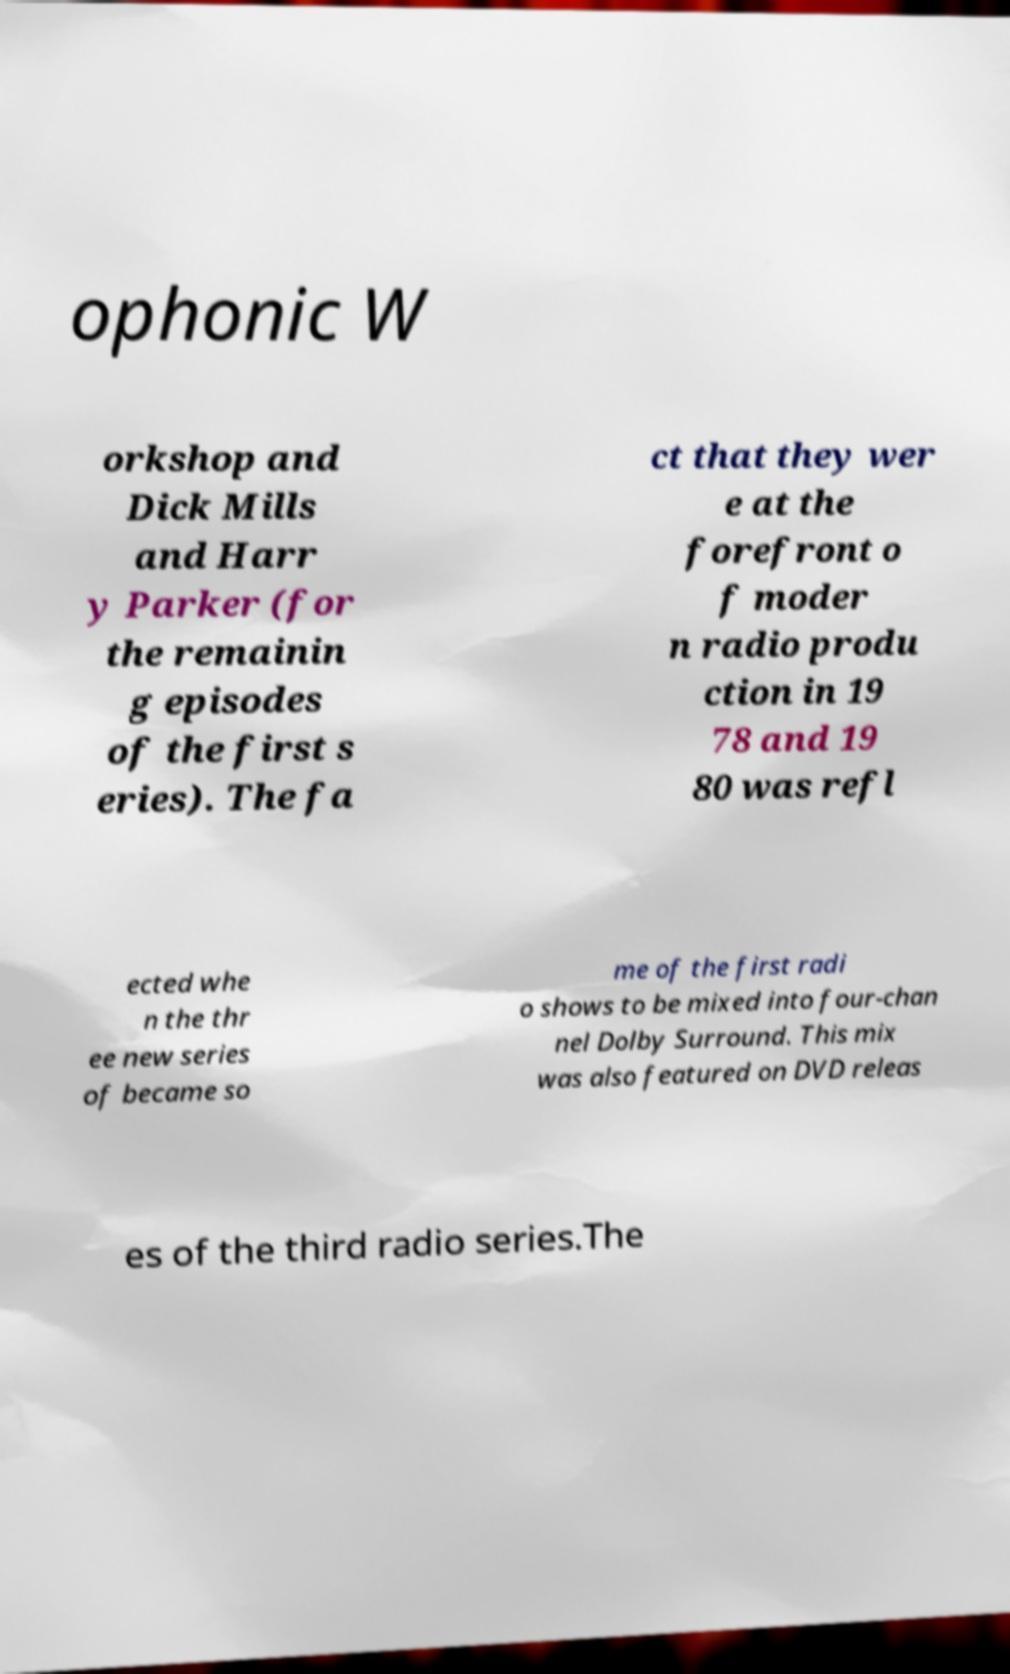For documentation purposes, I need the text within this image transcribed. Could you provide that? ophonic W orkshop and Dick Mills and Harr y Parker (for the remainin g episodes of the first s eries). The fa ct that they wer e at the forefront o f moder n radio produ ction in 19 78 and 19 80 was refl ected whe n the thr ee new series of became so me of the first radi o shows to be mixed into four-chan nel Dolby Surround. This mix was also featured on DVD releas es of the third radio series.The 